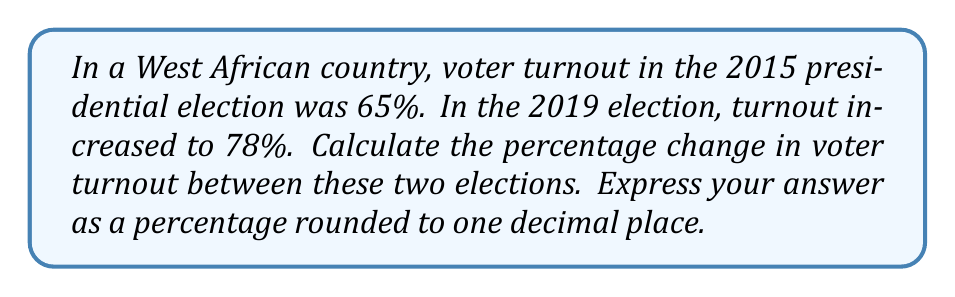Help me with this question. To calculate the percentage change in voter turnout, we'll use the following formula:

$$ \text{Percentage Change} = \frac{\text{New Value} - \text{Original Value}}{\text{Original Value}} \times 100\% $$

Let's plug in our values:
- Original Value (2015 turnout): 65%
- New Value (2019 turnout): 78%

$$ \text{Percentage Change} = \frac{78\% - 65\%}{65\%} \times 100\% $$

Simplifying:
$$ \text{Percentage Change} = \frac{13\%}{65\%} \times 100\% $$

$$ \text{Percentage Change} = 0.2 \times 100\% $$

$$ \text{Percentage Change} = 20\% $$

The percentage change is positive, indicating an increase in voter turnout.

Rounding to one decimal place: 20.0%
Answer: 20.0% 